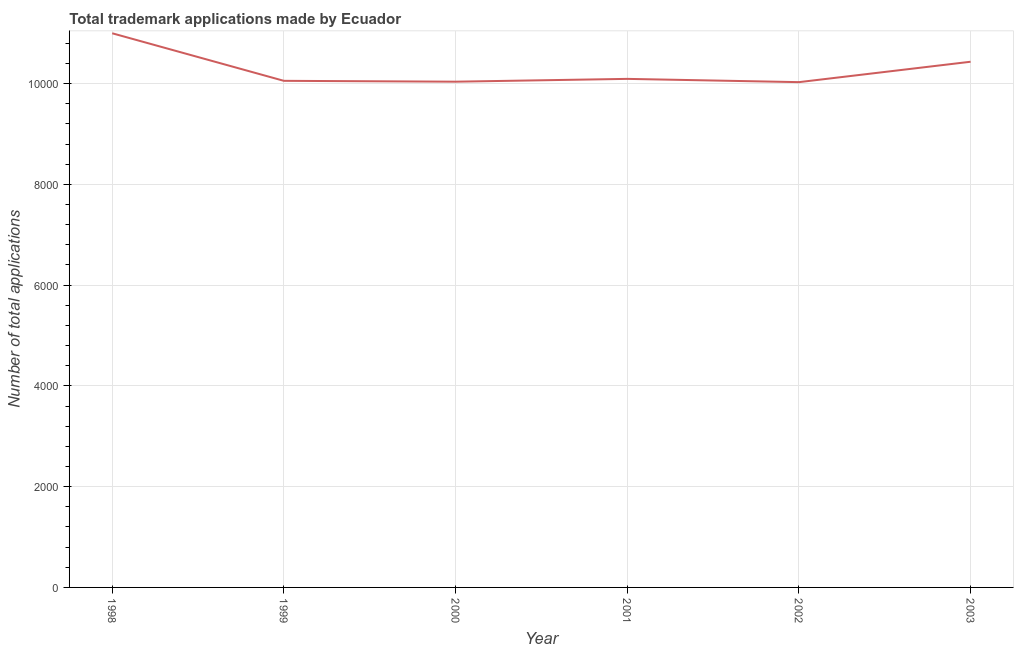What is the number of trademark applications in 2001?
Keep it short and to the point. 1.01e+04. Across all years, what is the maximum number of trademark applications?
Offer a terse response. 1.10e+04. Across all years, what is the minimum number of trademark applications?
Provide a short and direct response. 1.00e+04. In which year was the number of trademark applications minimum?
Offer a terse response. 2002. What is the sum of the number of trademark applications?
Your response must be concise. 6.16e+04. What is the difference between the number of trademark applications in 1998 and 1999?
Your answer should be compact. 944. What is the average number of trademark applications per year?
Give a very brief answer. 1.03e+04. What is the median number of trademark applications?
Provide a short and direct response. 1.01e+04. What is the ratio of the number of trademark applications in 1998 to that in 2003?
Provide a short and direct response. 1.05. Is the number of trademark applications in 1998 less than that in 2003?
Your answer should be very brief. No. What is the difference between the highest and the second highest number of trademark applications?
Keep it short and to the point. 565. Is the sum of the number of trademark applications in 2000 and 2002 greater than the maximum number of trademark applications across all years?
Make the answer very short. Yes. What is the difference between the highest and the lowest number of trademark applications?
Ensure brevity in your answer.  970. In how many years, is the number of trademark applications greater than the average number of trademark applications taken over all years?
Your response must be concise. 2. How many lines are there?
Your response must be concise. 1. Does the graph contain any zero values?
Keep it short and to the point. No. Does the graph contain grids?
Your answer should be compact. Yes. What is the title of the graph?
Provide a short and direct response. Total trademark applications made by Ecuador. What is the label or title of the Y-axis?
Provide a succinct answer. Number of total applications. What is the Number of total applications in 1998?
Give a very brief answer. 1.10e+04. What is the Number of total applications in 1999?
Offer a terse response. 1.01e+04. What is the Number of total applications of 2000?
Give a very brief answer. 1.00e+04. What is the Number of total applications in 2001?
Provide a succinct answer. 1.01e+04. What is the Number of total applications in 2002?
Give a very brief answer. 1.00e+04. What is the Number of total applications of 2003?
Offer a very short reply. 1.04e+04. What is the difference between the Number of total applications in 1998 and 1999?
Offer a very short reply. 944. What is the difference between the Number of total applications in 1998 and 2000?
Provide a succinct answer. 961. What is the difference between the Number of total applications in 1998 and 2001?
Your answer should be very brief. 905. What is the difference between the Number of total applications in 1998 and 2002?
Offer a very short reply. 970. What is the difference between the Number of total applications in 1998 and 2003?
Ensure brevity in your answer.  565. What is the difference between the Number of total applications in 1999 and 2001?
Provide a succinct answer. -39. What is the difference between the Number of total applications in 1999 and 2002?
Offer a terse response. 26. What is the difference between the Number of total applications in 1999 and 2003?
Offer a terse response. -379. What is the difference between the Number of total applications in 2000 and 2001?
Provide a succinct answer. -56. What is the difference between the Number of total applications in 2000 and 2002?
Your answer should be compact. 9. What is the difference between the Number of total applications in 2000 and 2003?
Keep it short and to the point. -396. What is the difference between the Number of total applications in 2001 and 2002?
Offer a terse response. 65. What is the difference between the Number of total applications in 2001 and 2003?
Offer a terse response. -340. What is the difference between the Number of total applications in 2002 and 2003?
Keep it short and to the point. -405. What is the ratio of the Number of total applications in 1998 to that in 1999?
Offer a very short reply. 1.09. What is the ratio of the Number of total applications in 1998 to that in 2000?
Give a very brief answer. 1.1. What is the ratio of the Number of total applications in 1998 to that in 2001?
Your answer should be very brief. 1.09. What is the ratio of the Number of total applications in 1998 to that in 2002?
Provide a succinct answer. 1.1. What is the ratio of the Number of total applications in 1998 to that in 2003?
Give a very brief answer. 1.05. What is the ratio of the Number of total applications in 1999 to that in 2002?
Provide a short and direct response. 1. What is the ratio of the Number of total applications in 2000 to that in 2001?
Make the answer very short. 0.99. What is the ratio of the Number of total applications in 2002 to that in 2003?
Provide a succinct answer. 0.96. 